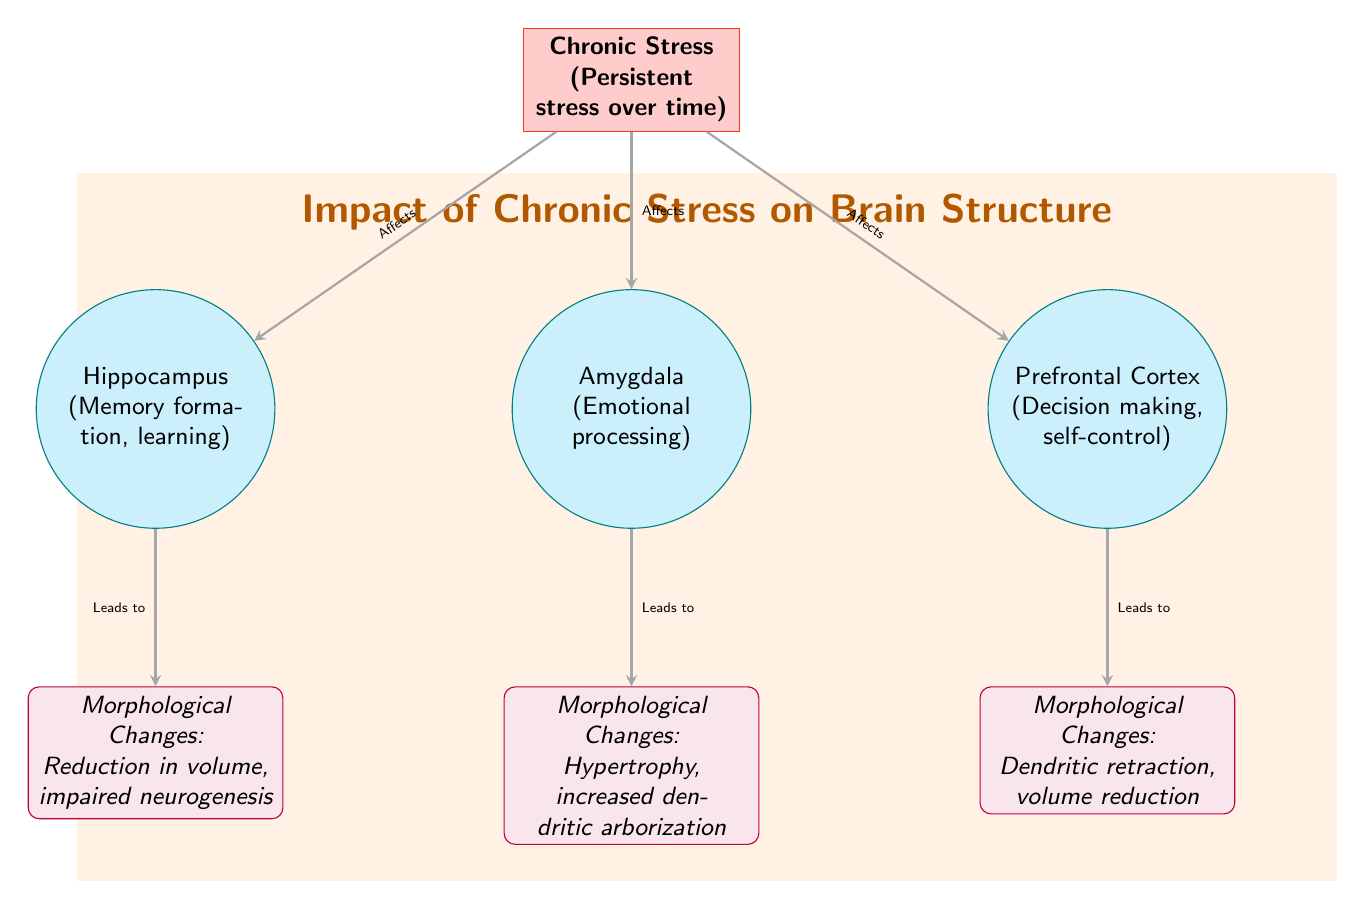What are the three brain regions affected by chronic stress? The diagram includes three brain regions: Hippocampus, Amygdala, and Prefrontal Cortex.
Answer: Hippocampus, Amygdala, Prefrontal Cortex What morphological change occurs in the hippocampus? According to the diagram, the morphological change in the hippocampus is a reduction in volume and impaired neurogenesis.
Answer: Reduction in volume, impaired neurogenesis Which brain region is associated with emotional processing? The diagram specifies that the Amygdala is the brain region associated with emotional processing.
Answer: Amygdala What type of change occurs in the amygdala due to chronic stress? The diagram indicates that hypertrophy and increased dendritic arborization occur in the amygdala due to chronic stress.
Answer: Hypertrophy, increased dendritic arborization How does chronic stress affect the prefrontal cortex? The diagram shows that chronic stress leads to dendritic retraction and volume reduction in the prefrontal cortex.
Answer: Dendritic retraction, volume reduction What is the relationship between chronic stress and the hippocampus? From the diagram, chronic stress affects the hippocampus, leading to morphological changes related to memory formation and learning.
Answer: Affects Which brain region's changes result in impaired neurogenesis? Based on the diagram, impaired neurogenesis is specifically associated with changes in the hippocampus.
Answer: Hippocampus What is the primary effect of chronic stress on brain structure? The diagram highlights that chronic stress leads to various morphological changes across multiple brain regions affecting cognition and emotion.
Answer: Morphological changes How many total brain regions are depicted in the diagram? The diagram represents three brain regions: Hippocampus, Amygdala, and Prefrontal Cortex. Thus, the total number is three.
Answer: 3 